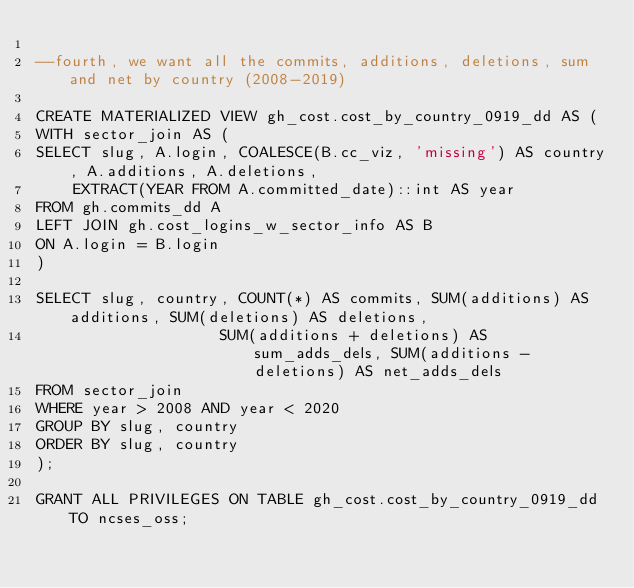Convert code to text. <code><loc_0><loc_0><loc_500><loc_500><_SQL_>
--fourth, we want all the commits, additions, deletions, sum and net by country (2008-2019)

CREATE MATERIALIZED VIEW gh_cost.cost_by_country_0919_dd AS (
WITH sector_join AS (
SELECT slug, A.login, COALESCE(B.cc_viz, 'missing') AS country, A.additions, A.deletions,
	EXTRACT(YEAR FROM A.committed_date)::int AS year
FROM gh.commits_dd A
LEFT JOIN gh.cost_logins_w_sector_info AS B
ON A.login = B.login
)

SELECT slug, country, COUNT(*) AS commits, SUM(additions) AS additions, SUM(deletions) AS deletions,
					SUM(additions + deletions) AS sum_adds_dels, SUM(additions - deletions) AS net_adds_dels
FROM sector_join
WHERE year > 2008 AND year < 2020
GROUP BY slug, country
ORDER BY slug, country
);

GRANT ALL PRIVILEGES ON TABLE gh_cost.cost_by_country_0919_dd TO ncses_oss;
</code> 